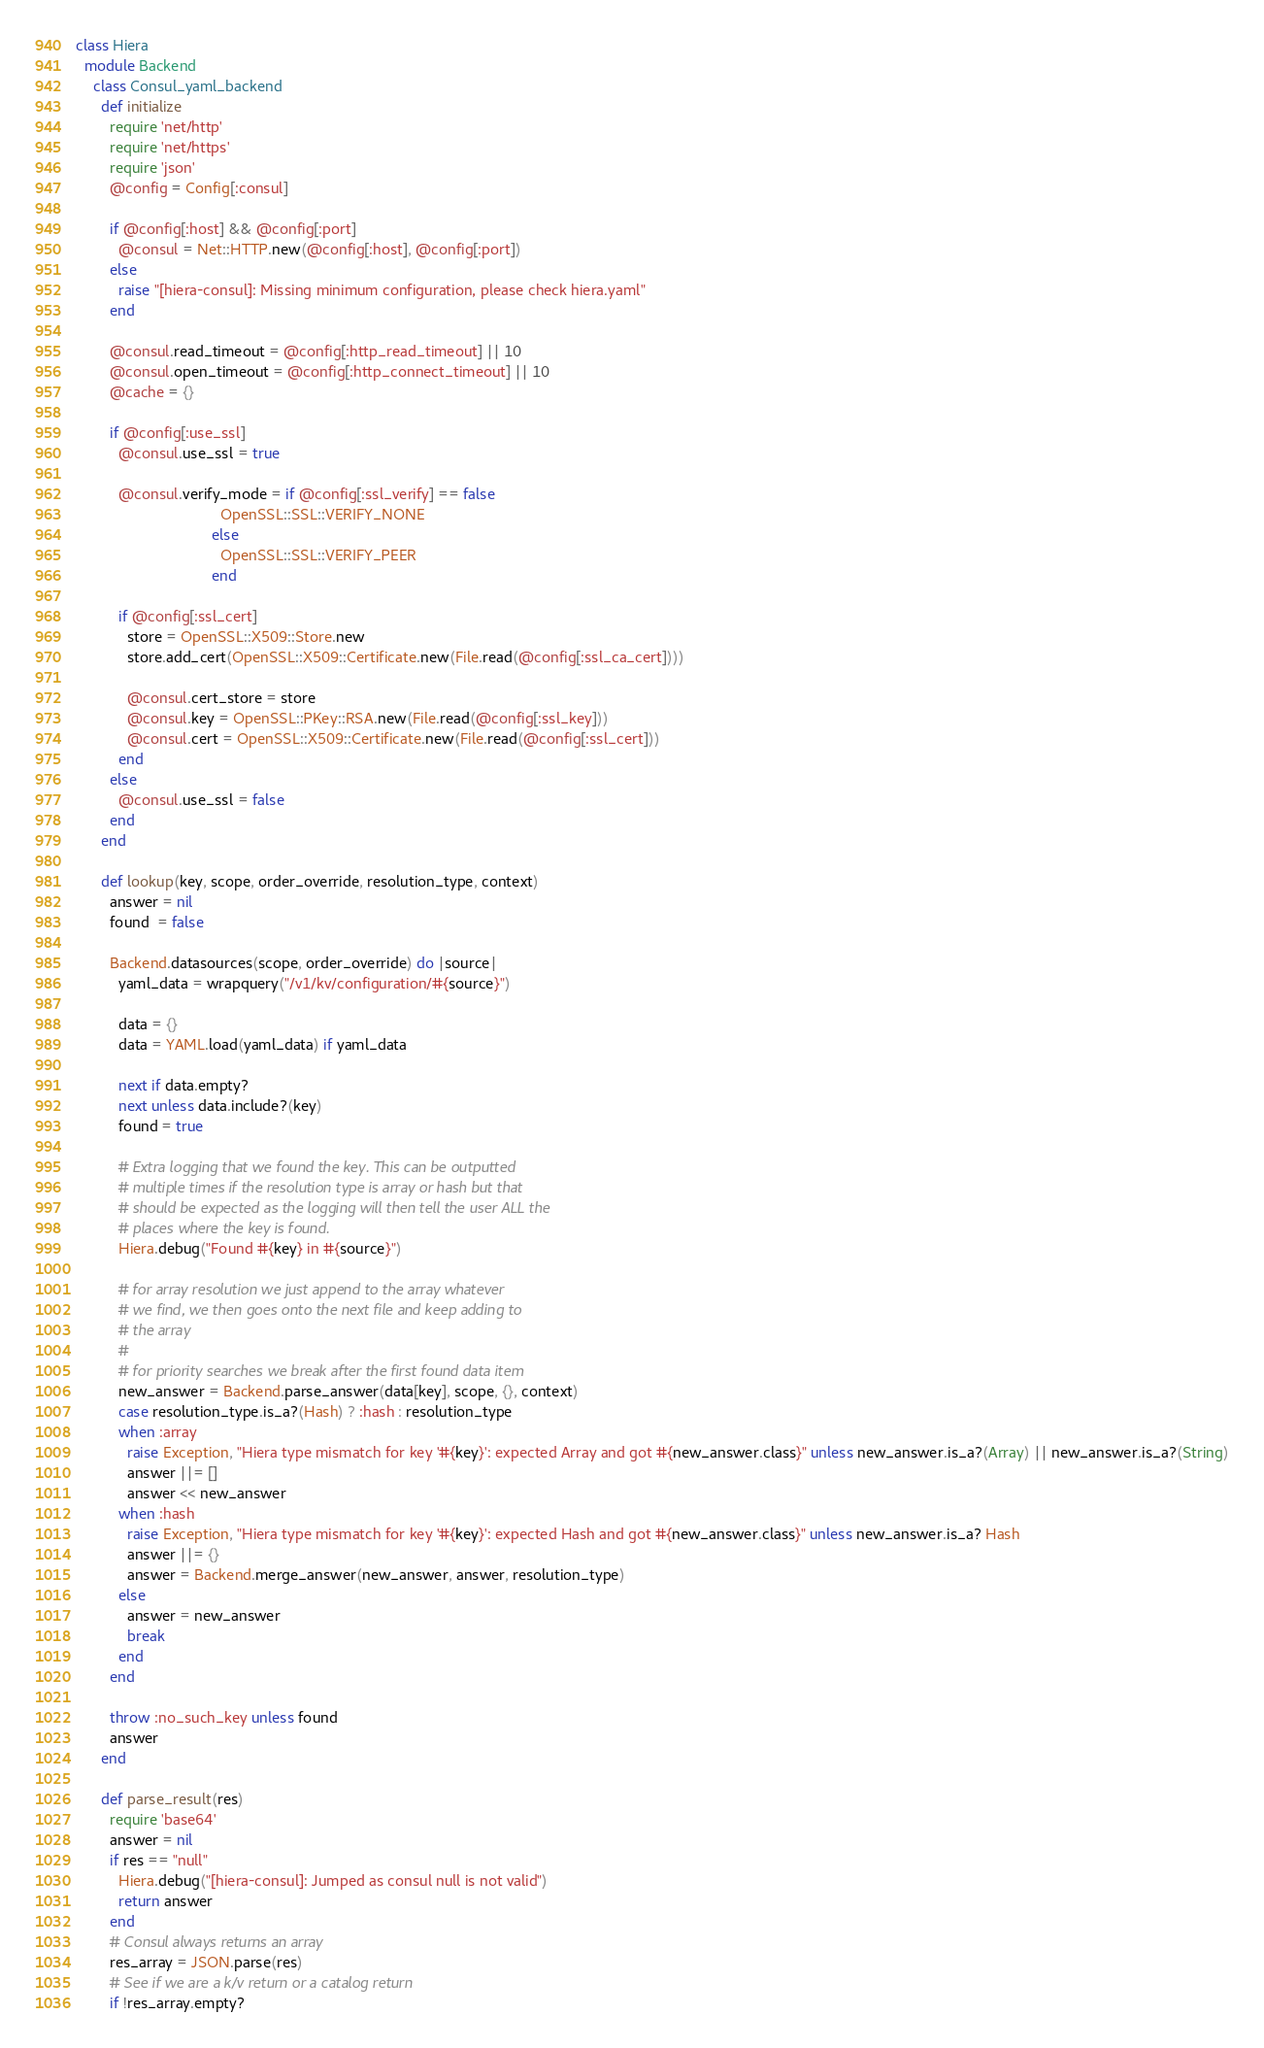Convert code to text. <code><loc_0><loc_0><loc_500><loc_500><_Ruby_>class Hiera
  module Backend
    class Consul_yaml_backend
      def initialize
        require 'net/http'
        require 'net/https'
        require 'json'
        @config = Config[:consul]

        if @config[:host] && @config[:port]
          @consul = Net::HTTP.new(@config[:host], @config[:port])
        else
          raise "[hiera-consul]: Missing minimum configuration, please check hiera.yaml"
        end

        @consul.read_timeout = @config[:http_read_timeout] || 10
        @consul.open_timeout = @config[:http_connect_timeout] || 10
        @cache = {}

        if @config[:use_ssl]
          @consul.use_ssl = true

          @consul.verify_mode = if @config[:ssl_verify] == false
                                  OpenSSL::SSL::VERIFY_NONE
                                else
                                  OpenSSL::SSL::VERIFY_PEER
                                end

          if @config[:ssl_cert]
            store = OpenSSL::X509::Store.new
            store.add_cert(OpenSSL::X509::Certificate.new(File.read(@config[:ssl_ca_cert])))

            @consul.cert_store = store
            @consul.key = OpenSSL::PKey::RSA.new(File.read(@config[:ssl_key]))
            @consul.cert = OpenSSL::X509::Certificate.new(File.read(@config[:ssl_cert]))
          end
        else
          @consul.use_ssl = false
        end
      end

      def lookup(key, scope, order_override, resolution_type, context)
        answer = nil
        found  = false

        Backend.datasources(scope, order_override) do |source|
          yaml_data = wrapquery("/v1/kv/configuration/#{source}")

          data = {}
          data = YAML.load(yaml_data) if yaml_data

          next if data.empty?
          next unless data.include?(key)
          found = true

          # Extra logging that we found the key. This can be outputted
          # multiple times if the resolution type is array or hash but that
          # should be expected as the logging will then tell the user ALL the
          # places where the key is found.
          Hiera.debug("Found #{key} in #{source}")

          # for array resolution we just append to the array whatever
          # we find, we then goes onto the next file and keep adding to
          # the array
          #
          # for priority searches we break after the first found data item
          new_answer = Backend.parse_answer(data[key], scope, {}, context)
          case resolution_type.is_a?(Hash) ? :hash : resolution_type
          when :array
            raise Exception, "Hiera type mismatch for key '#{key}': expected Array and got #{new_answer.class}" unless new_answer.is_a?(Array) || new_answer.is_a?(String)
            answer ||= []
            answer << new_answer
          when :hash
            raise Exception, "Hiera type mismatch for key '#{key}': expected Hash and got #{new_answer.class}" unless new_answer.is_a? Hash
            answer ||= {}
            answer = Backend.merge_answer(new_answer, answer, resolution_type)
          else
            answer = new_answer
            break
          end
        end

        throw :no_such_key unless found
        answer
      end

      def parse_result(res)
        require 'base64'
        answer = nil
        if res == "null"
          Hiera.debug("[hiera-consul]: Jumped as consul null is not valid")
          return answer
        end
        # Consul always returns an array
        res_array = JSON.parse(res)
        # See if we are a k/v return or a catalog return
        if !res_array.empty?</code> 